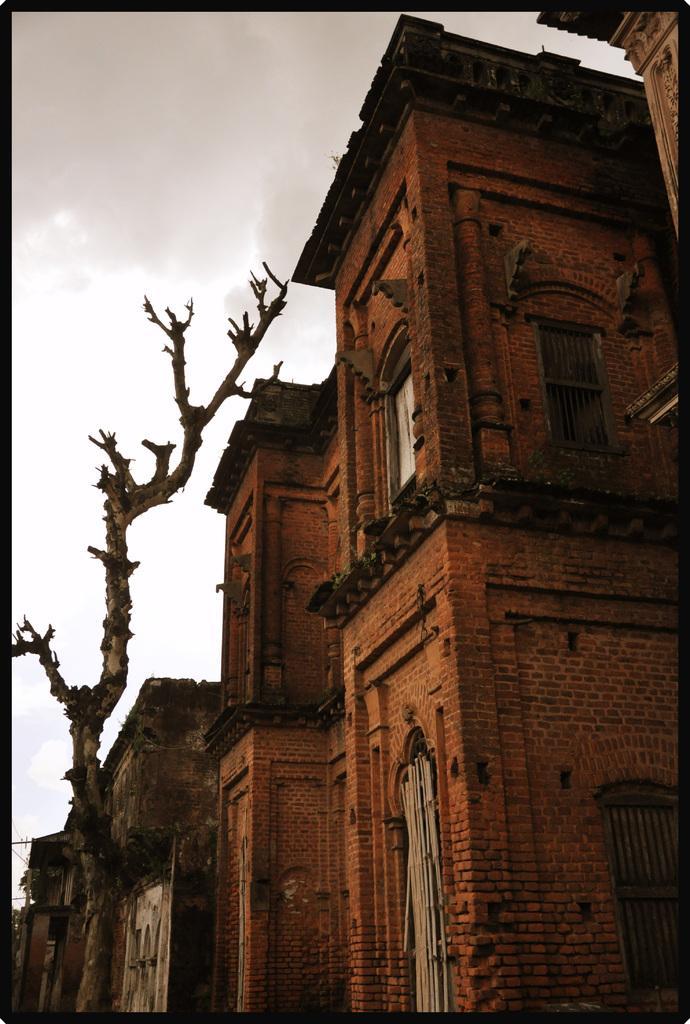Describe this image in one or two sentences. In this image I can see the building with windows. The building is in brown color. To the left I can see the trunk. In the background I can see the clouds and the sky. 